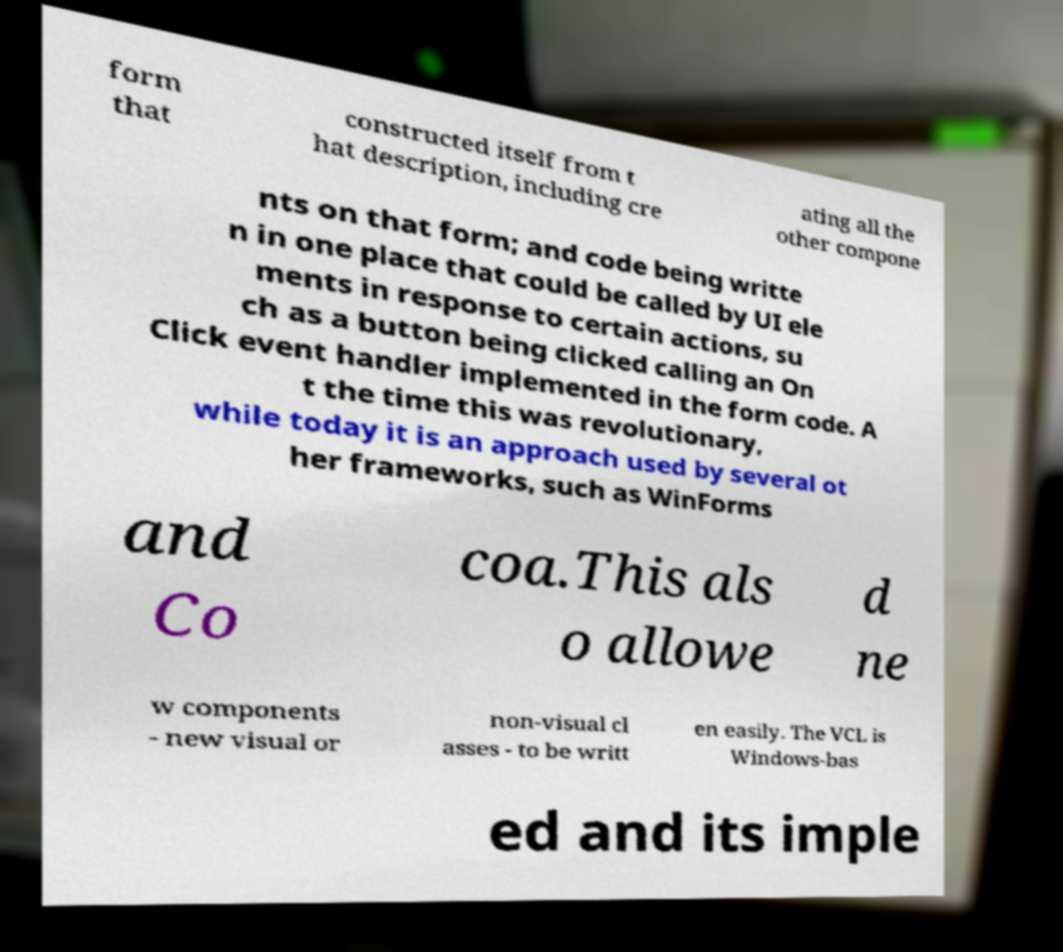What messages or text are displayed in this image? I need them in a readable, typed format. form that constructed itself from t hat description, including cre ating all the other compone nts on that form; and code being writte n in one place that could be called by UI ele ments in response to certain actions, su ch as a button being clicked calling an On Click event handler implemented in the form code. A t the time this was revolutionary, while today it is an approach used by several ot her frameworks, such as WinForms and Co coa.This als o allowe d ne w components - new visual or non-visual cl asses - to be writt en easily. The VCL is Windows-bas ed and its imple 